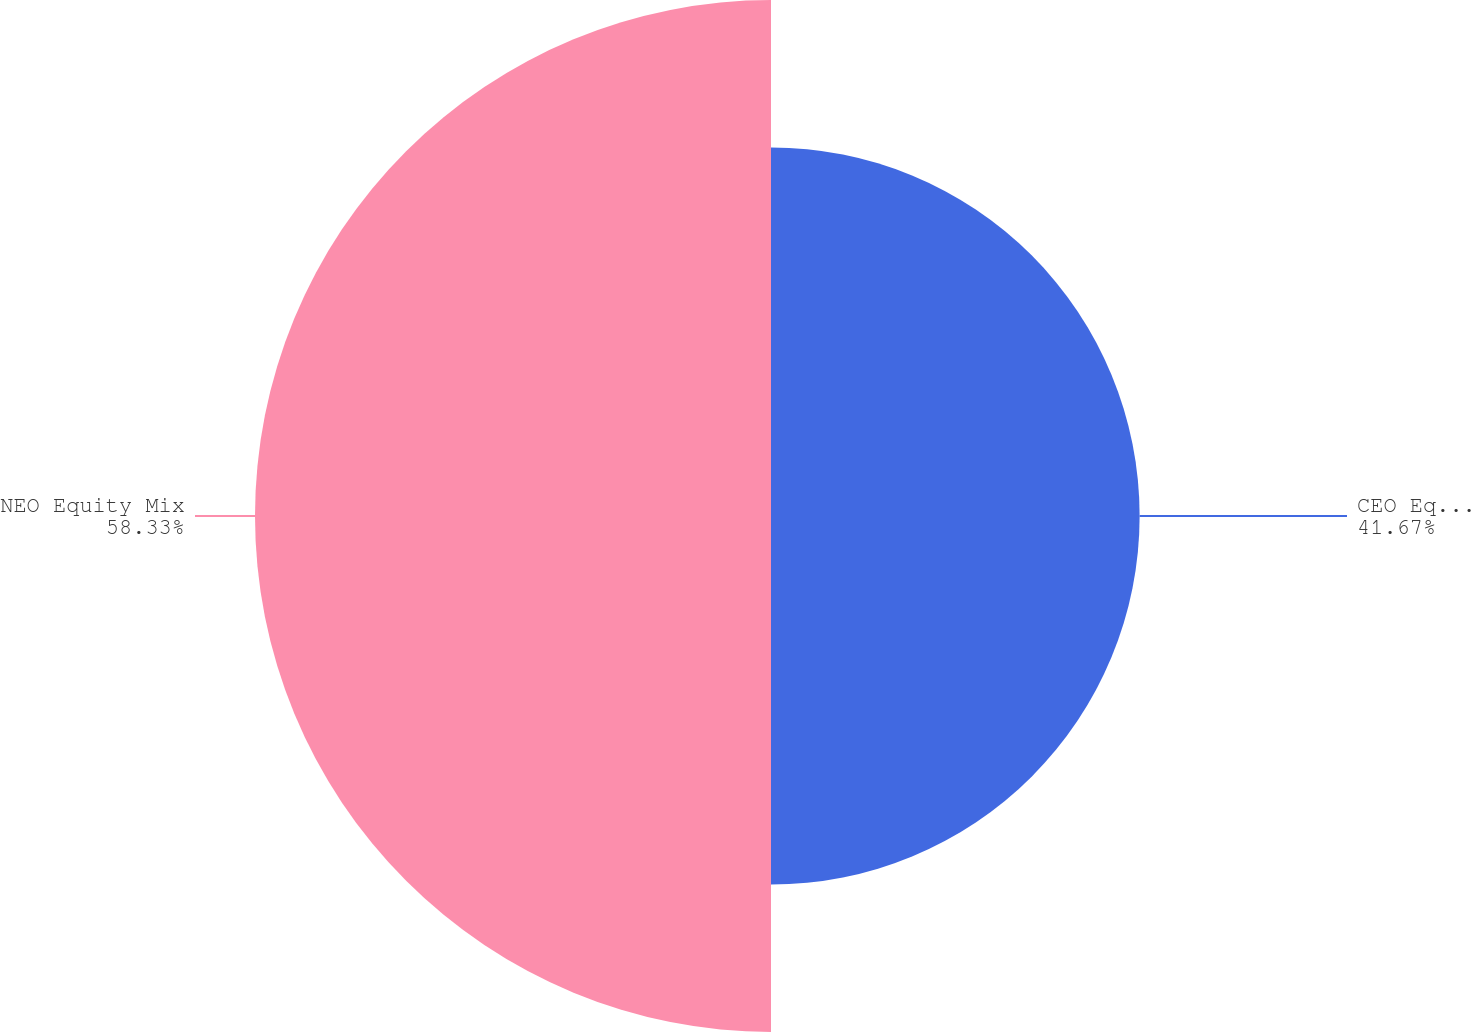Convert chart to OTSL. <chart><loc_0><loc_0><loc_500><loc_500><pie_chart><fcel>CEO Equity Mix<fcel>NEO Equity Mix<nl><fcel>41.67%<fcel>58.33%<nl></chart> 